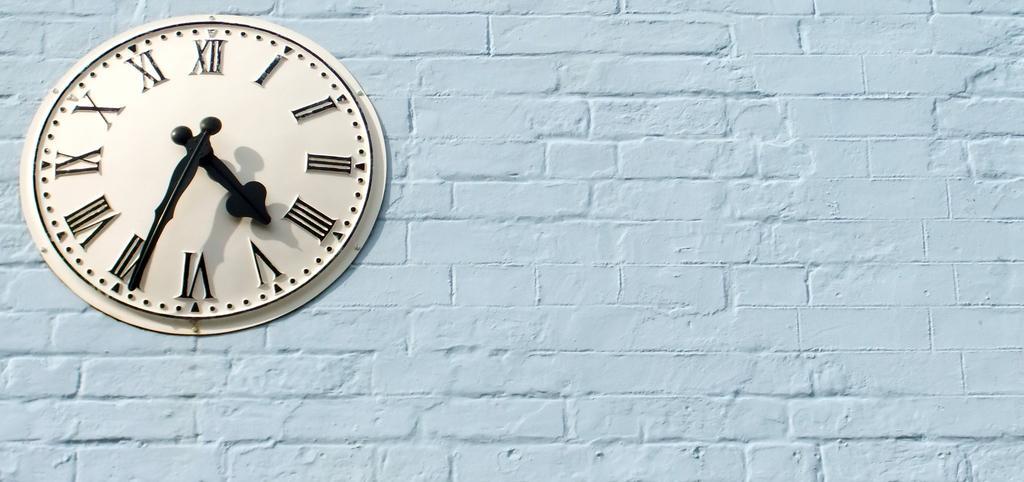Please provide a concise description of this image. In this image there is a clock attached to the wall. On the clock there are roman numbers and there is a short hand and a long hand. 